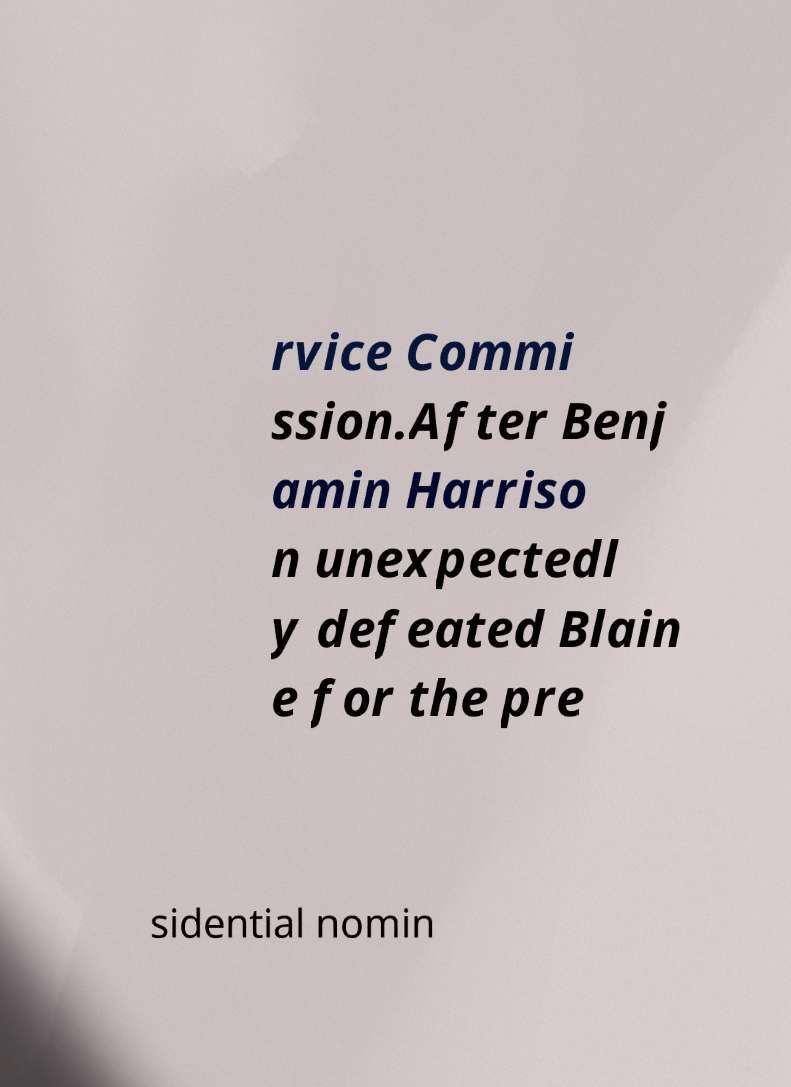Please identify and transcribe the text found in this image. rvice Commi ssion.After Benj amin Harriso n unexpectedl y defeated Blain e for the pre sidential nomin 